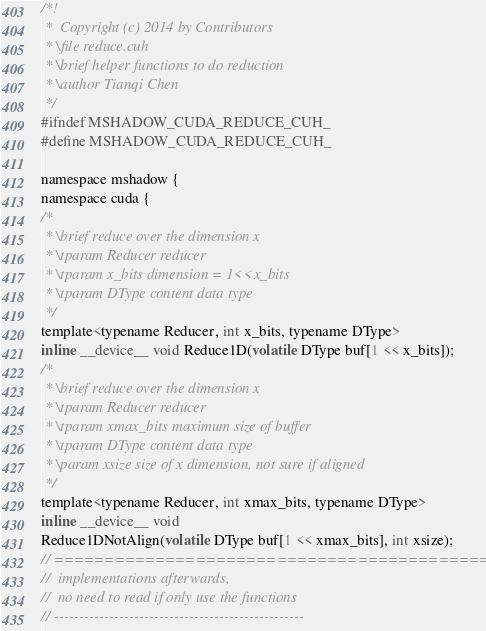Convert code to text. <code><loc_0><loc_0><loc_500><loc_500><_Cuda_>/*!
 *  Copyright (c) 2014 by Contributors
 * \file reduce.cuh
 * \brief helper functions to do reduction
 * \author Tianqi Chen
 */
#ifndef MSHADOW_CUDA_REDUCE_CUH_
#define MSHADOW_CUDA_REDUCE_CUH_

namespace mshadow {
namespace cuda {
/*
 * \brief reduce over the dimension x
 * \tparam Reducer reducer
 * \tparam x_bits dimension = 1<<x_bits
 * \tparam DType content data type
 */
template<typename Reducer, int x_bits, typename DType>
inline __device__ void Reduce1D(volatile DType buf[1 << x_bits]);
/*
 * \brief reduce over the dimension x
 * \tparam Reducer reducer
 * \tparam xmax_bits maximum size of buffer
 * \tparam DType content data type
 * \param xsize size of x dimension, not sure if aligned
 */
template<typename Reducer, int xmax_bits, typename DType>
inline __device__ void
Reduce1DNotAlign(volatile DType buf[1 << xmax_bits], int xsize);
// ===============================================x===
//  implementations afterwards,
//  no need to read if only use the functions
// --------------------------------------------------</code> 